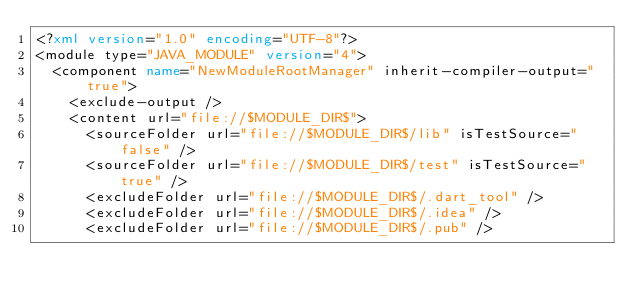Convert code to text. <code><loc_0><loc_0><loc_500><loc_500><_XML_><?xml version="1.0" encoding="UTF-8"?>
<module type="JAVA_MODULE" version="4">
  <component name="NewModuleRootManager" inherit-compiler-output="true">
    <exclude-output />
    <content url="file://$MODULE_DIR$">
      <sourceFolder url="file://$MODULE_DIR$/lib" isTestSource="false" />
      <sourceFolder url="file://$MODULE_DIR$/test" isTestSource="true" />
      <excludeFolder url="file://$MODULE_DIR$/.dart_tool" />
      <excludeFolder url="file://$MODULE_DIR$/.idea" />
      <excludeFolder url="file://$MODULE_DIR$/.pub" /></code> 